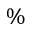<formula> <loc_0><loc_0><loc_500><loc_500>\%</formula> 